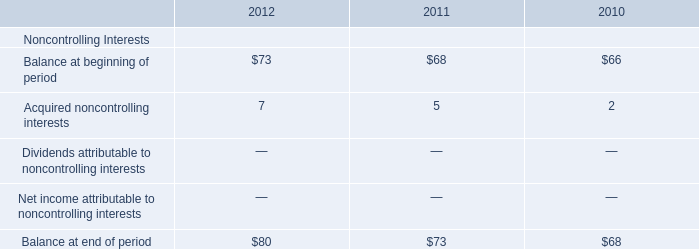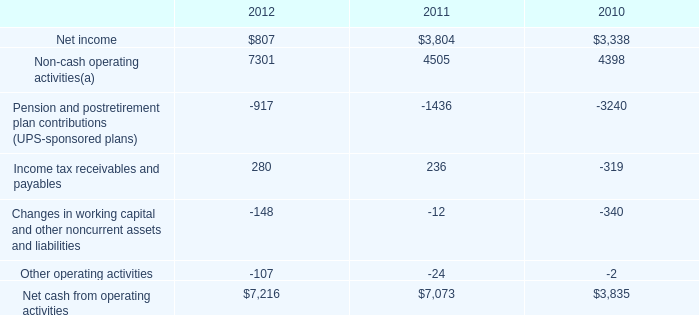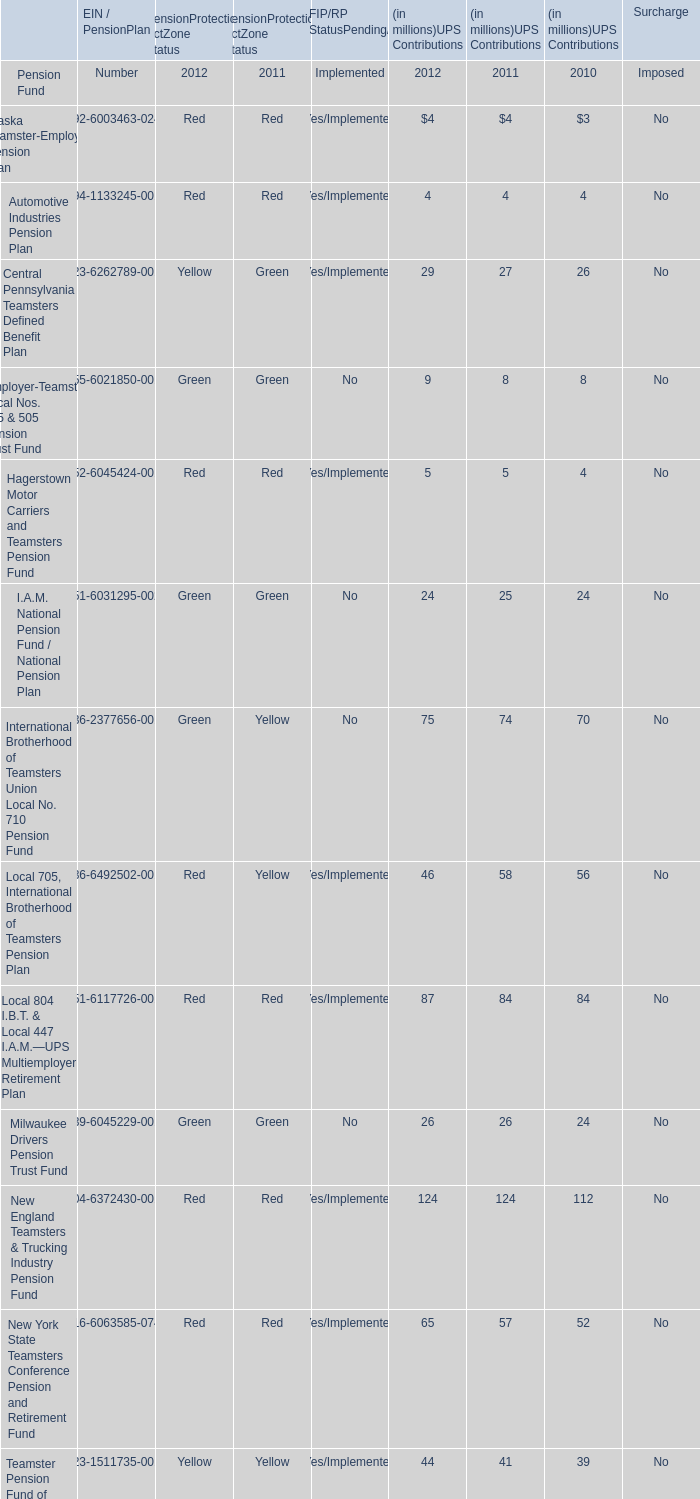what is the growth rate in the net income from 2011 to 2012? 
Computations: ((807 - 3804) / 3804)
Answer: -0.78785. 